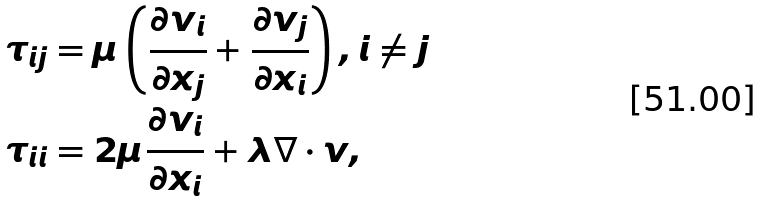Convert formula to latex. <formula><loc_0><loc_0><loc_500><loc_500>\tau _ { i j } & = \mu \left ( \frac { \partial v _ { i } } { \partial x _ { j } } + \frac { \partial v _ { j } } { \partial x _ { i } } \right ) , i \neq j \\ \tau _ { i i } & = 2 \mu \frac { \partial v _ { i } } { \partial x _ { i } } + \lambda \nabla \cdot v ,</formula> 